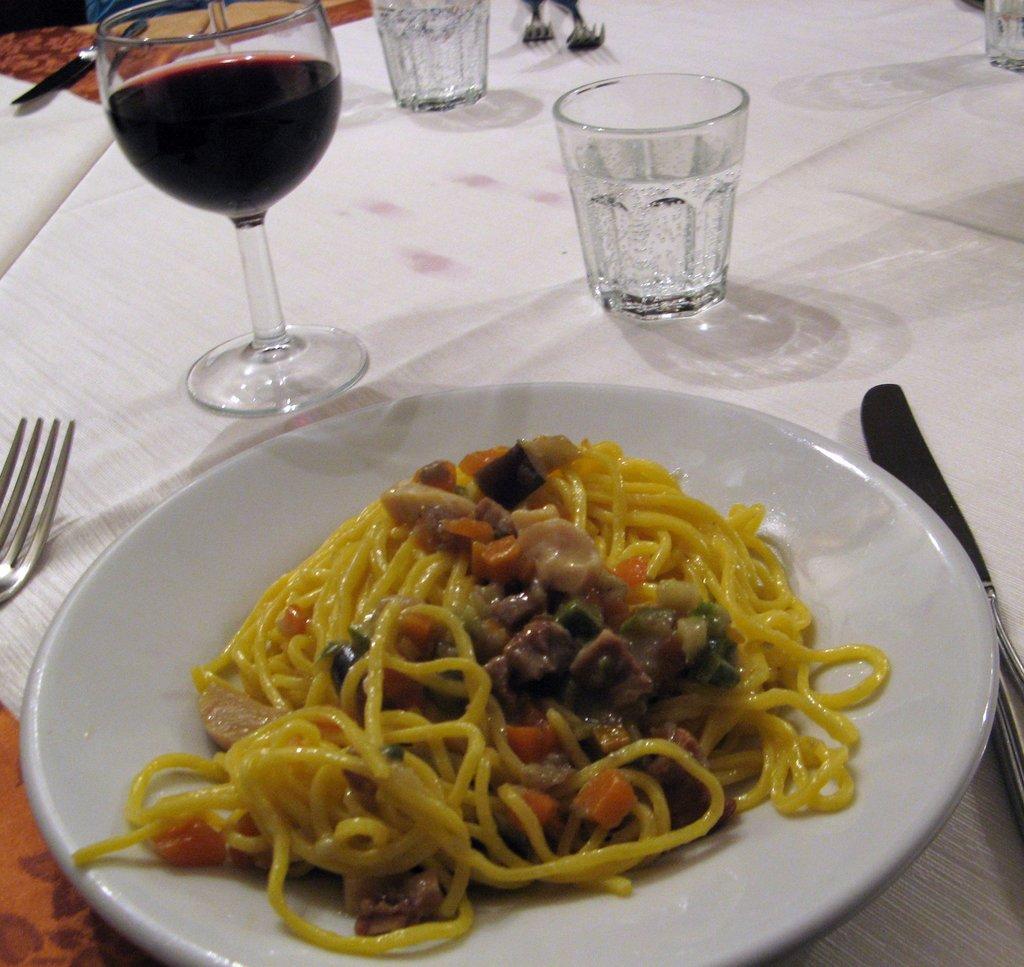Please provide a concise description of this image. In this image we can see some food in a plate, glasses with some liquid in it, a fork, knives and a cloth which are placed on the table. 